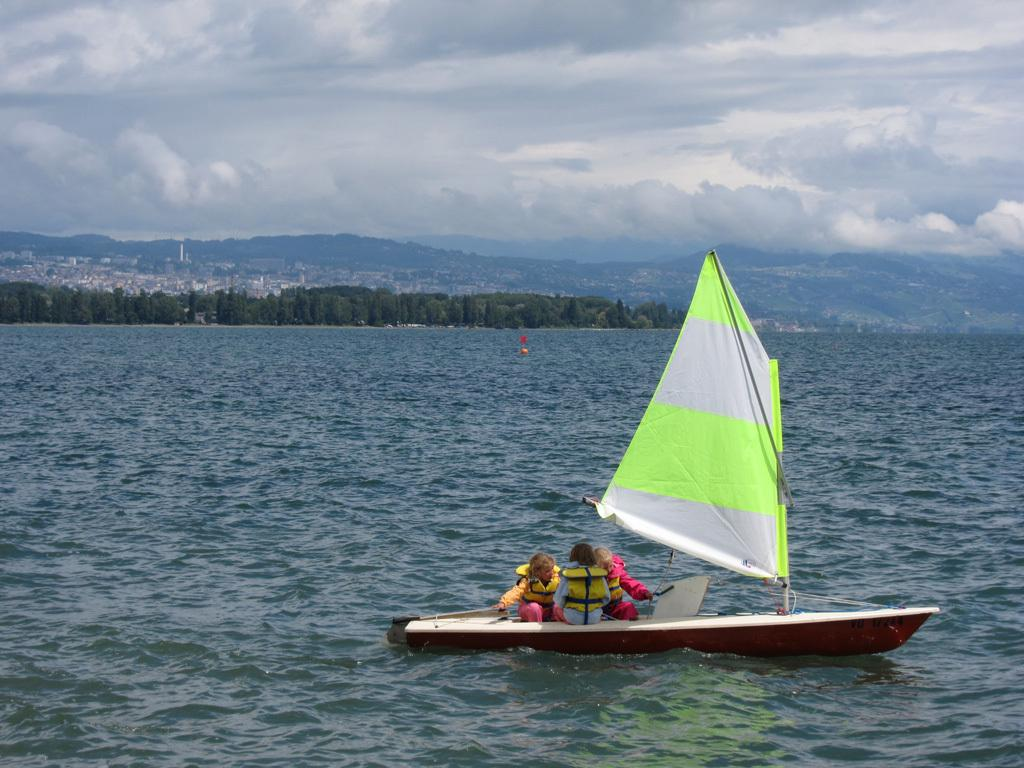What body of water is present in the image? There is a river in the image. What is on the river in the image? There is a boat on the river. Who is in the boat in the image? There are people sitting in the boat. What can be seen in the background of the image? There are trees, buildings, hills, and the sky visible in the background of the image. What type of tooth is being used to rake the leaves in the image? There is no tooth or rake present in the image; it features a river, a boat, and people. 